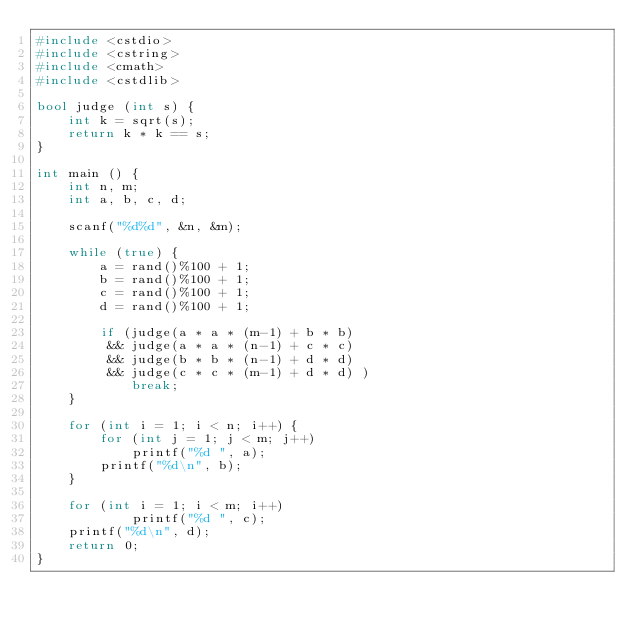Convert code to text. <code><loc_0><loc_0><loc_500><loc_500><_C++_>#include <cstdio>
#include <cstring>
#include <cmath>
#include <cstdlib>

bool judge (int s) {
	int k = sqrt(s);
	return k * k == s;
}

int main () {
	int n, m;
	int a, b, c, d;

	scanf("%d%d", &n, &m);

	while (true) {
		a = rand()%100 + 1;
		b = rand()%100 + 1;
		c = rand()%100 + 1;
		d = rand()%100 + 1;

		if (judge(a * a * (m-1) + b * b)
		 && judge(a * a * (n-1) + c * c)
		 && judge(b * b * (n-1) + d * d)
		 && judge(c * c * (m-1) + d * d) )
			break;
	}

	for (int i = 1; i < n; i++) {
		for (int j = 1; j < m; j++)
			printf("%d ", a);
		printf("%d\n", b);
	}

	for (int i = 1; i < m; i++)
			printf("%d ", c);
	printf("%d\n", d);
	return 0;
}
</code> 